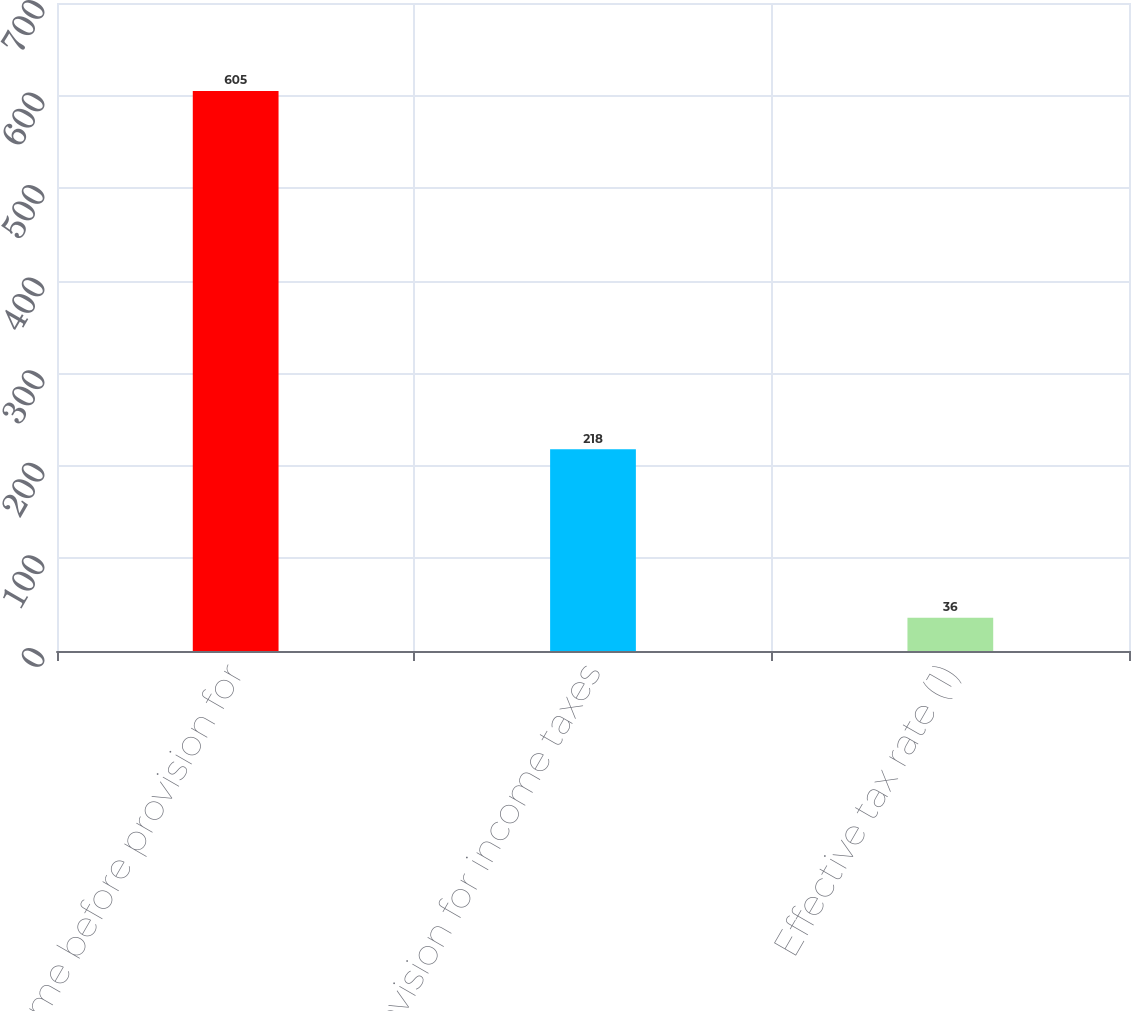Convert chart to OTSL. <chart><loc_0><loc_0><loc_500><loc_500><bar_chart><fcel>Income before provision for<fcel>Provision for income taxes<fcel>Effective tax rate (1)<nl><fcel>605<fcel>218<fcel>36<nl></chart> 